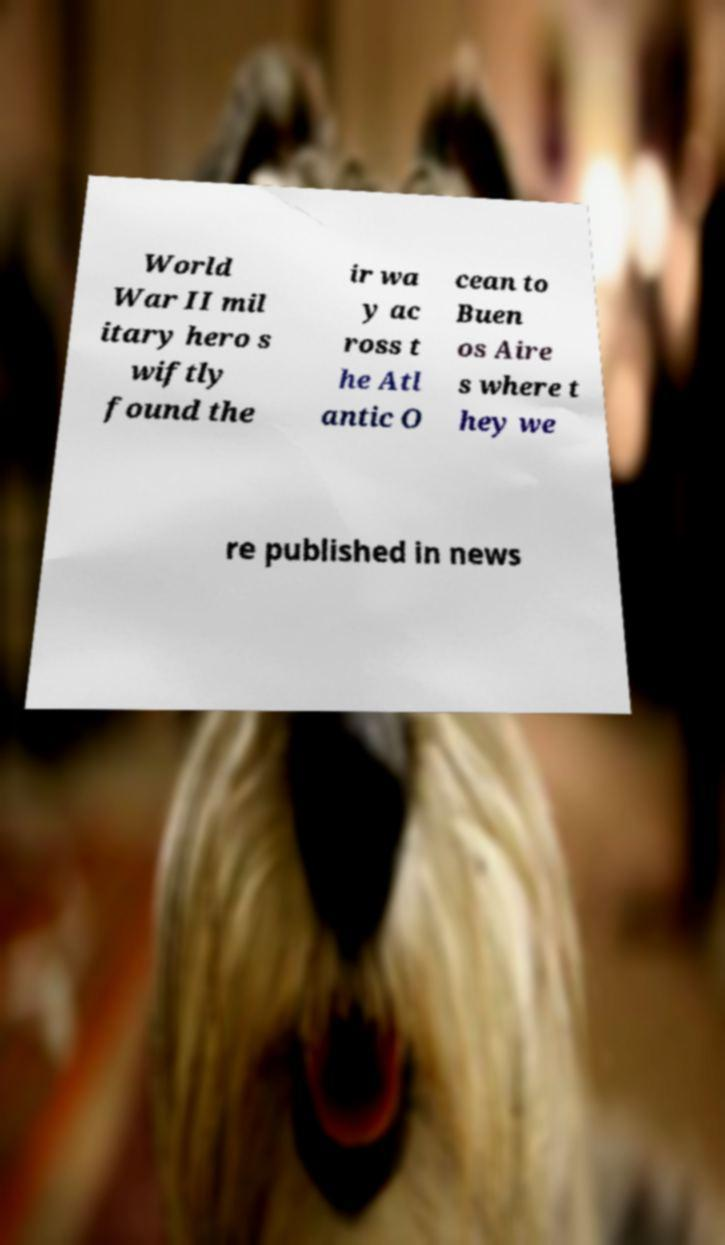I need the written content from this picture converted into text. Can you do that? World War II mil itary hero s wiftly found the ir wa y ac ross t he Atl antic O cean to Buen os Aire s where t hey we re published in news 